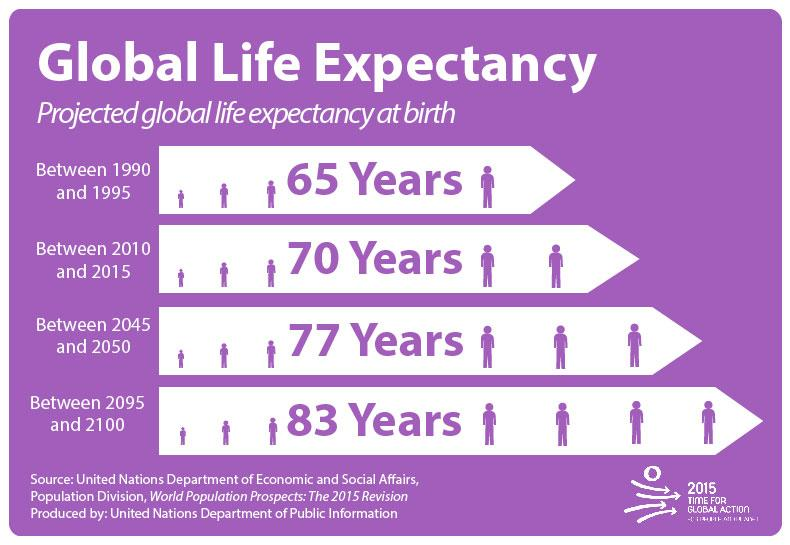Outline some significant characteristics in this image. This infographic contains four ages mentioned. 